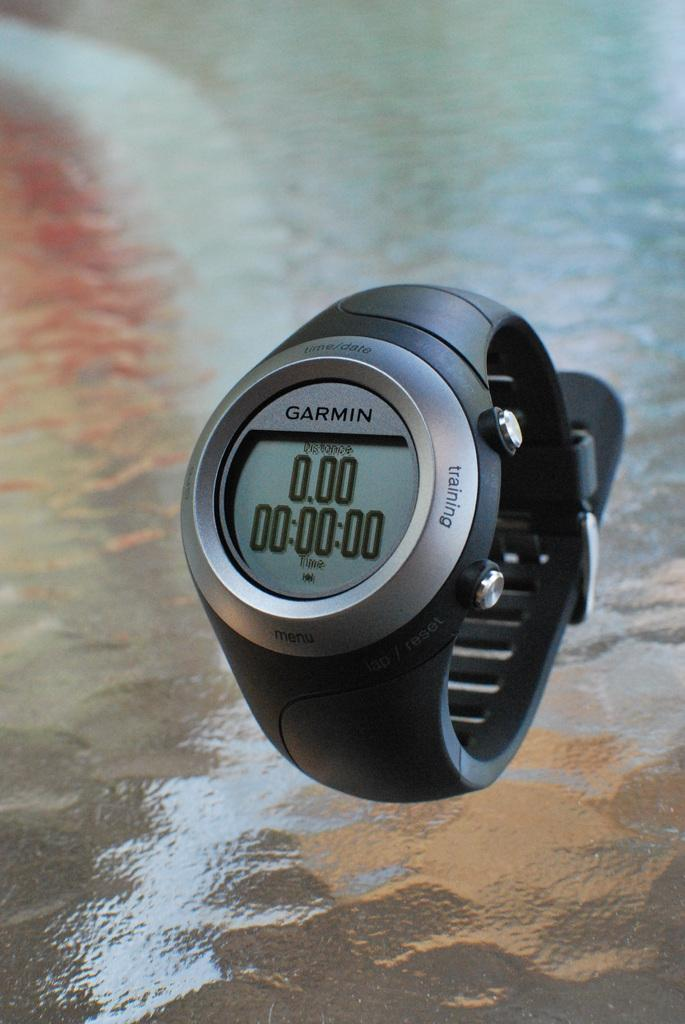<image>
Summarize the visual content of the image. The Garmin watch has a black wrist band. 